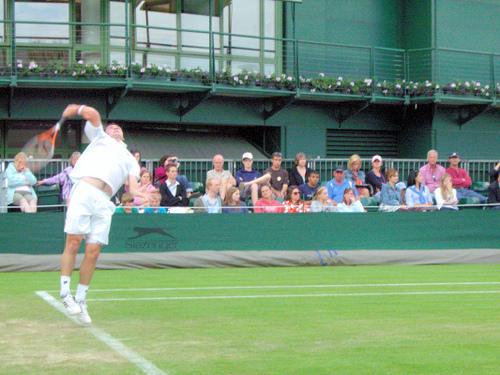Is the entire audience watching the tennis player?
Answer briefly. No. What color is the building behind the people?
Keep it brief. Green. What is around the edge of the balcony?
Write a very short answer. Flowers. 